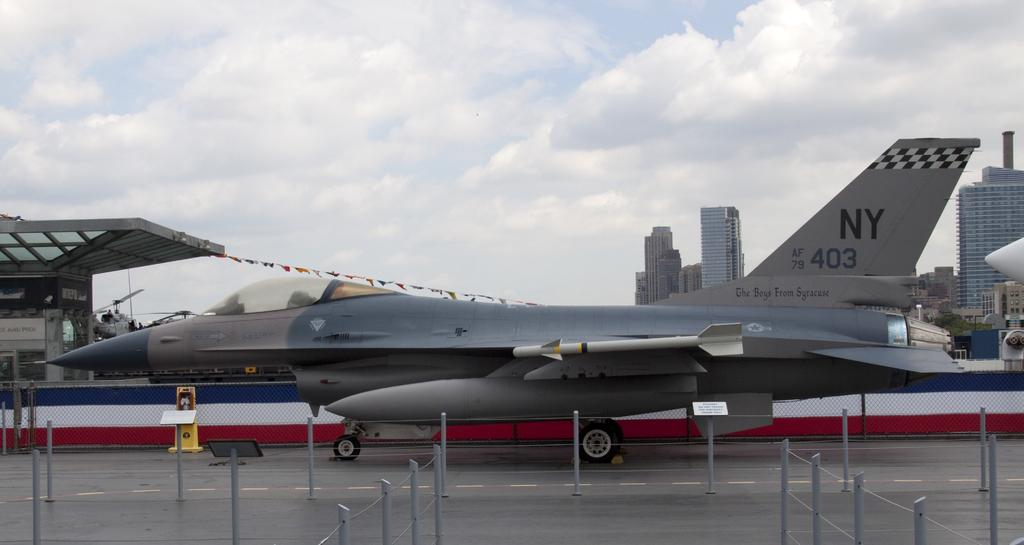<image>
Relay a brief, clear account of the picture shown. An NY 403 military jet is on the runway 